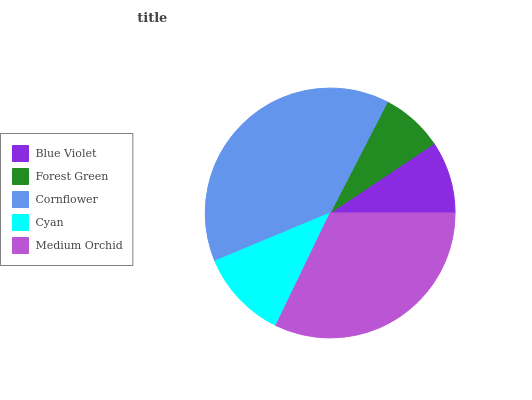Is Forest Green the minimum?
Answer yes or no. Yes. Is Cornflower the maximum?
Answer yes or no. Yes. Is Cornflower the minimum?
Answer yes or no. No. Is Forest Green the maximum?
Answer yes or no. No. Is Cornflower greater than Forest Green?
Answer yes or no. Yes. Is Forest Green less than Cornflower?
Answer yes or no. Yes. Is Forest Green greater than Cornflower?
Answer yes or no. No. Is Cornflower less than Forest Green?
Answer yes or no. No. Is Cyan the high median?
Answer yes or no. Yes. Is Cyan the low median?
Answer yes or no. Yes. Is Medium Orchid the high median?
Answer yes or no. No. Is Blue Violet the low median?
Answer yes or no. No. 